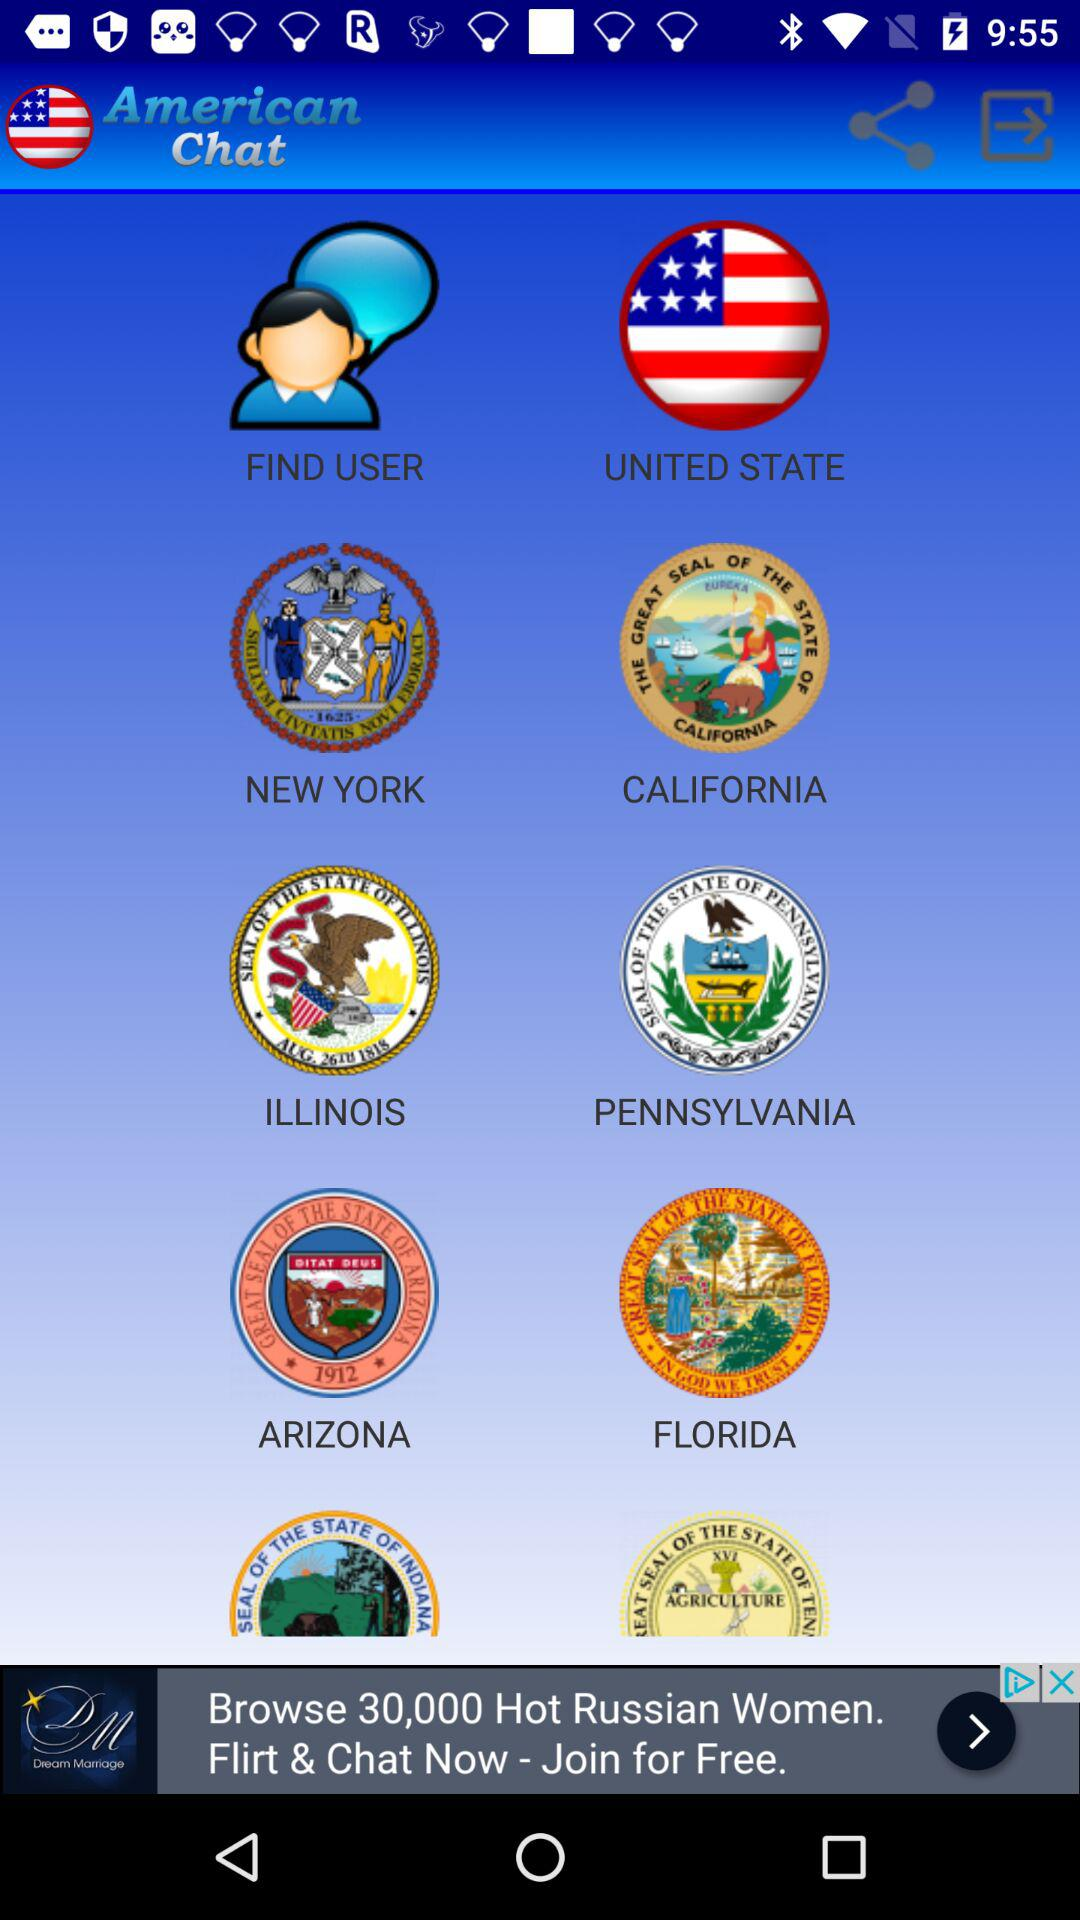What is the application name? The application name is "American Chat". 